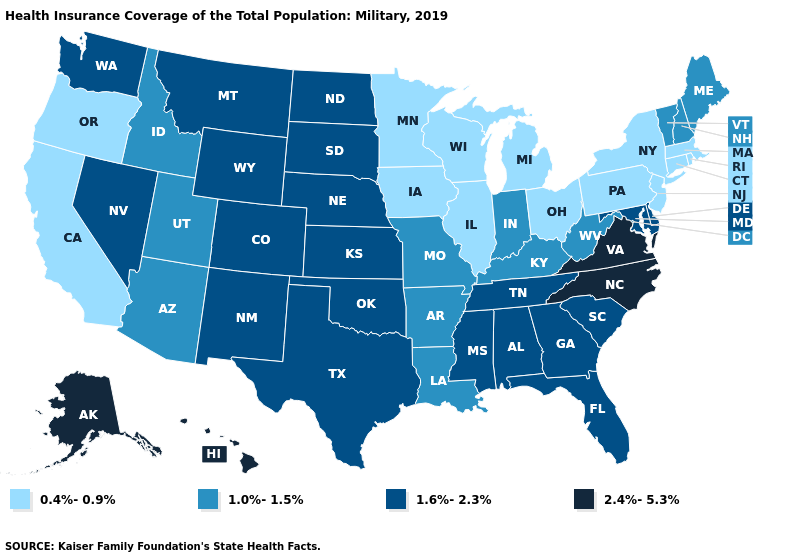Does Idaho have the lowest value in the USA?
Concise answer only. No. Among the states that border New Jersey , does New York have the lowest value?
Give a very brief answer. Yes. Is the legend a continuous bar?
Short answer required. No. Among the states that border New Hampshire , which have the lowest value?
Short answer required. Massachusetts. What is the highest value in the USA?
Short answer required. 2.4%-5.3%. What is the value of Idaho?
Answer briefly. 1.0%-1.5%. What is the highest value in states that border Maryland?
Short answer required. 2.4%-5.3%. What is the value of California?
Be succinct. 0.4%-0.9%. Does Kentucky have the highest value in the South?
Quick response, please. No. Is the legend a continuous bar?
Answer briefly. No. Does the first symbol in the legend represent the smallest category?
Short answer required. Yes. Name the states that have a value in the range 2.4%-5.3%?
Quick response, please. Alaska, Hawaii, North Carolina, Virginia. Does the first symbol in the legend represent the smallest category?
Concise answer only. Yes. What is the value of Connecticut?
Short answer required. 0.4%-0.9%. Does Michigan have the same value as Utah?
Concise answer only. No. 